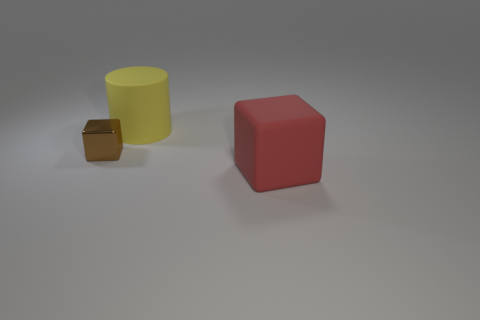How many objects are either brown cubes or blocks that are left of the large yellow rubber object?
Provide a succinct answer. 1. How many other things are the same material as the brown object?
Keep it short and to the point. 0. How many things are big red blocks or big yellow cylinders?
Ensure brevity in your answer.  2. Is the number of large rubber things behind the big red matte object greater than the number of large cylinders that are in front of the small thing?
Your answer should be very brief. Yes. What size is the matte thing that is in front of the big thing that is left of the large rubber object that is on the right side of the big cylinder?
Offer a terse response. Large. What is the color of the other tiny object that is the same shape as the red object?
Offer a terse response. Brown. Is the number of large matte objects that are to the right of the big yellow matte cylinder greater than the number of tiny green cubes?
Provide a succinct answer. Yes. Does the large red object have the same shape as the object to the left of the large yellow object?
Ensure brevity in your answer.  Yes. Is there any other thing that has the same size as the brown metallic block?
Make the answer very short. No. What size is the brown shiny thing that is the same shape as the red object?
Ensure brevity in your answer.  Small. 